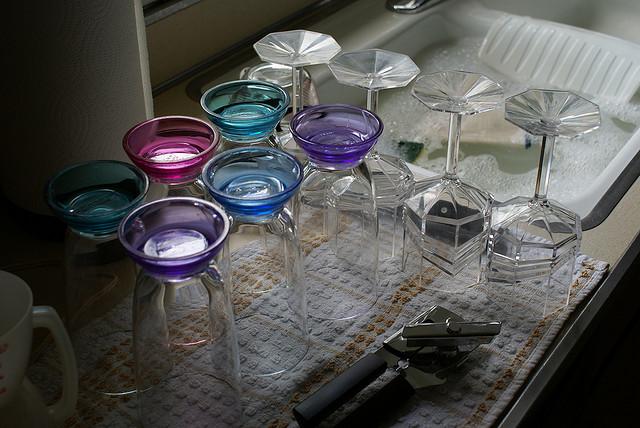Are these made of plastic?
Answer briefly. No. Is this the way you wash dishes?
Give a very brief answer. Yes. How warm is the water in the sink?
Short answer required. Hot. 